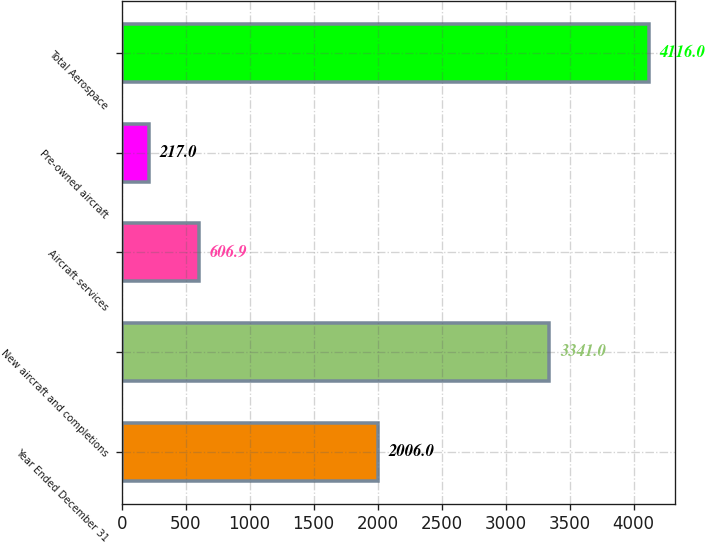<chart> <loc_0><loc_0><loc_500><loc_500><bar_chart><fcel>Year Ended December 31<fcel>New aircraft and completions<fcel>Aircraft services<fcel>Pre-owned aircraft<fcel>Total Aerospace<nl><fcel>2006<fcel>3341<fcel>606.9<fcel>217<fcel>4116<nl></chart> 